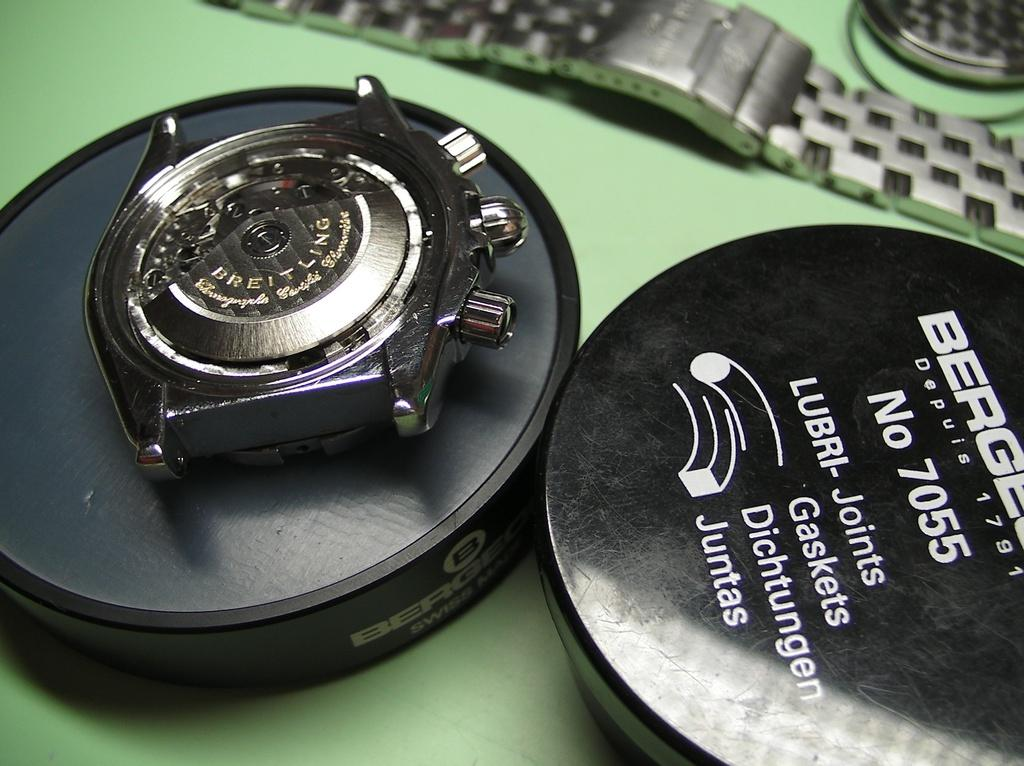<image>
Summarize the visual content of the image. A close of up of a Breitling watch mechanism and some lubri-joints 